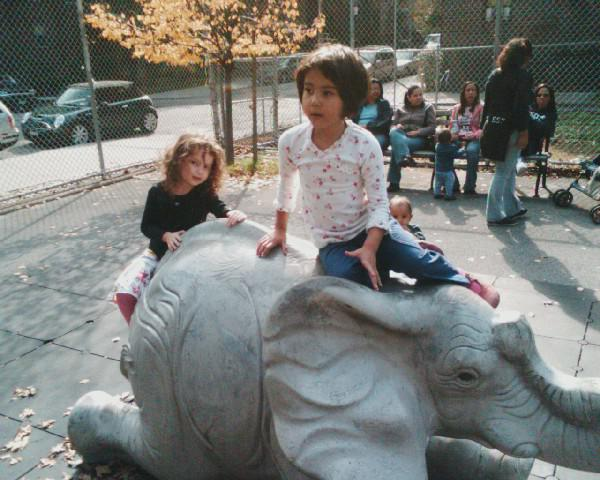Question: what animal are the children climbing on?
Choices:
A. A monkey.
B. A bear.
C. A lion.
D. An elephant.
Answer with the letter. Answer: D Question: what are the two girls doing?
Choices:
A. Dancing.
B. Playing.
C. Singing.
D. Running.
Answer with the letter. Answer: B Question: when was this picture taken?
Choices:
A. At Sunset.
B. Early Spring.
C. When the snow first started to fall.
D. During the day.
Answer with the letter. Answer: D Question: why isn't the toddler climbing?
Choices:
A. He is too small.
B. His legs are too short.
C. He doesn't have the strength yet.
D. He is tired.
Answer with the letter. Answer: A Question: what is the elephant made of?
Choices:
A. Stone.
B. Flesh.
C. Gold.
D. Wood.
Answer with the letter. Answer: A Question: who is sitting on the bench?
Choices:
A. The homeless people.
B. The children.
C. The moms.
D. Workers on coffee break.
Answer with the letter. Answer: C Question: what has yellow leaves?
Choices:
A. The flower.
B. The water weed.
C. The tree.
D. The decorated flower girl.
Answer with the letter. Answer: C Question: when is this scene taking place?
Choices:
A. During the night.
B. On a sunday.
C. In new year's eve.
D. During the day.
Answer with the letter. Answer: D Question: what can the kids play on?
Choices:
A. Jungle gym.
B. A toy elephant.
C. Bounce house.
D. Rug.
Answer with the letter. Answer: B Question: who was approaching behind the girls on the elephant?
Choices:
A. A man.
B. A toddler.
C. A woman.
D. A child.
Answer with the letter. Answer: B Question: where are the leaves?
Choices:
A. On the lawn.
B. In a trash bag.
C. On the tree.
D. Falling off of the tree.
Answer with the letter. Answer: D Question: what is parked in the street?
Choices:
A. Cars.
B. Motorcycles.
C. Buses.
D. Taxi cabs.
Answer with the letter. Answer: A Question: where was the photo taken?
Choices:
A. Outdoors.
B. In the open air.
C. At the park.
D. At the recreation area.
Answer with the letter. Answer: C Question: what is near the bench?
Choices:
A. There are shrubs close to the bench.
B. A tree.
C. A water faucet is near the bench.
D. There is a trash can beside the bench.
Answer with the letter. Answer: B Question: what color shirt is one of the girls wearing?
Choices:
A. Blue.
B. White.
C. Black.
D. Red.
Answer with the letter. Answer: C Question: who has a black bag?
Choices:
A. A girl.
B. One of the women.
C. A man.
D. A boy.
Answer with the letter. Answer: B Question: who is with the adults?
Choices:
A. A dog.
B. A teenager.
C. A toddler.
D. A child.
Answer with the letter. Answer: C 